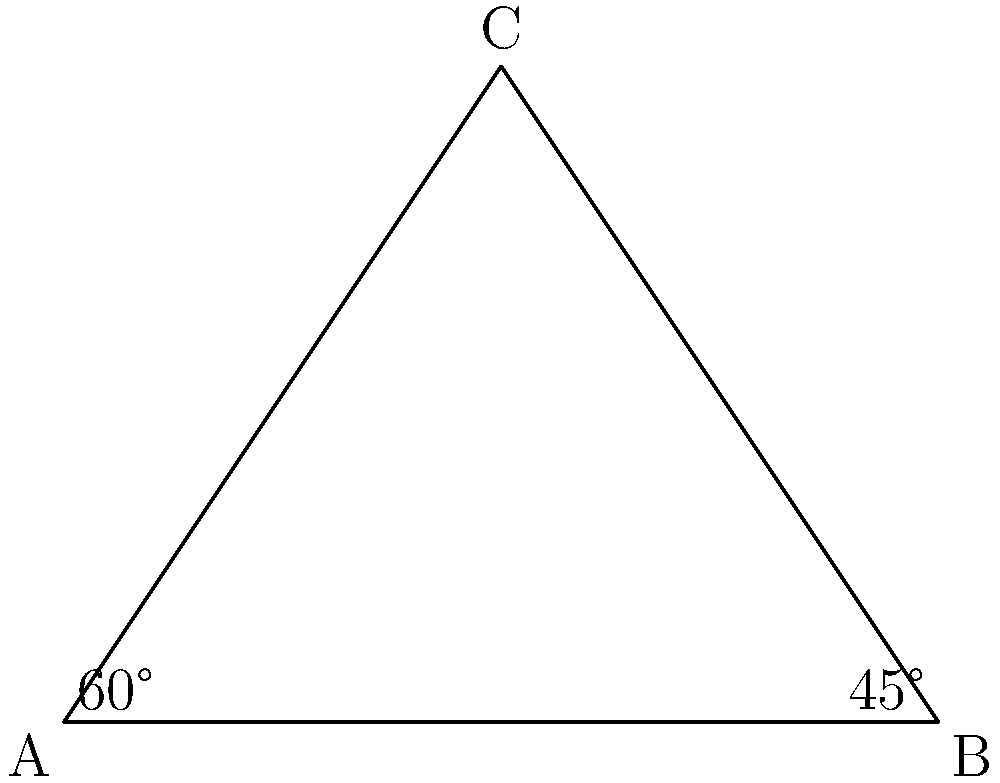In a triangular breathing exercise diagram, angle A is 60° and angle B is 45°. What is the measure of angle C? To find the measure of angle C, we can follow these steps:

1) Recall that the sum of angles in a triangle is always 180°.

2) Let's denote the measure of angle C as $x$.

3) We can set up an equation:
   $60° + 45° + x = 180°$

4) Simplify the left side of the equation:
   $105° + x = 180°$

5) Subtract 105° from both sides:
   $x = 180° - 105°$

6) Perform the subtraction:
   $x = 75°$

Therefore, the measure of angle C is 75°.

7) We can verify this result:
   $60° + 45° + 75° = 180°$

This confirms that our solution is correct, as the sum of all angles equals 180°.
Answer: 75° 